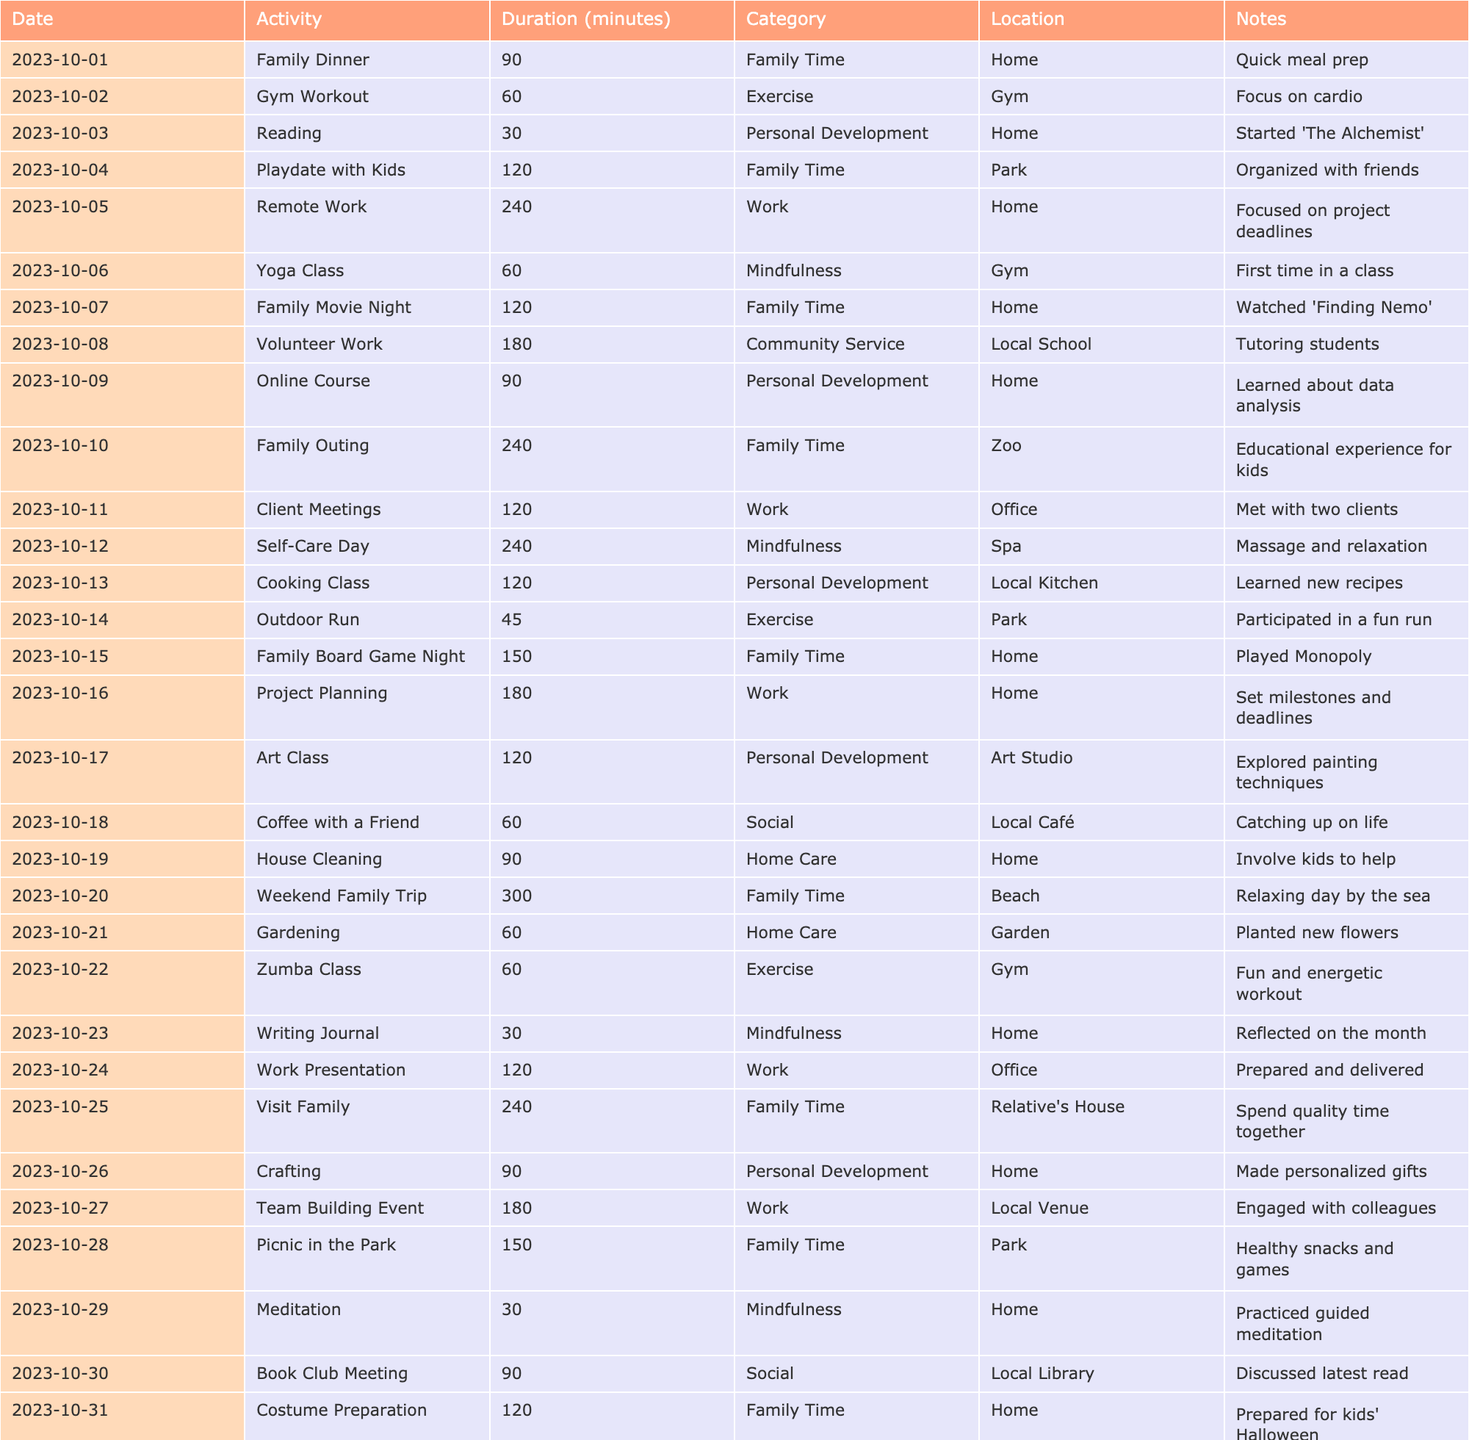What activity had the longest duration? Looking at the "Duration" column, the longest entry is "Weekend Family Trip" with 300 minutes.
Answer: Weekend Family Trip How many activities were related to family time? By counting the entries in the "Category" for Family Time, there are 8 such activities: Family Dinner, Playdate with Kids, Family Movie Night, Family Outing, Family Board Game Night, Weekend Family Trip, Visit Family, and Picnic in the Park.
Answer: 8 What was the total time spent on work-related activities? Summing the durations of the work-related activities (Remote Work 240 + Client Meetings 120 + Project Planning 180 + Work Presentation 120 + Team Building Event 180) gives 240 + 120 + 180 + 120 + 180 = 840 minutes.
Answer: 840 minutes Did the person engage in any mindfulness activities? By checking the table, the activities categorized under Mindfulness are Yoga Class, Self-Care Day, Writing Journal, and Meditation, confirming that there were mindfulness activities.
Answer: Yes What is the average duration of personal development activities? The personal development activities are Reading (30), Online Course (90), Cooking Class (120), Art Class (120), and Crafting (90). Their total is 30 + 90 + 120 + 120 + 90 = 450 minutes; the average is 450 / 5 = 90 minutes.
Answer: 90 minutes Which day had the least amount of time spent on activities? Evaluating the duration of activities by day, the lowest is "Meditation" on the 29th with 30 minutes.
Answer: Meditation on the 29th How many of the total activities were done at home? The activities done at home are Family Dinner, Remote Work, Family Movie Night, Online Course, Self-Care Day, Writing Journal, House Cleaning, and Costume Preparation, totaling 8.
Answer: 8 What percentage of the month's activities were related to family time? There are 31 activities in total and 8 of them relate to family time, so the percentage is (8/31) * 100 = approximately 25.8%.
Answer: Approximately 25.8% Was there an activity related to community service? Yes, "Volunteer Work" on the 8th is categorized under Community Service.
Answer: Yes What was the total time spent on exercise-related activities? Adding the durations of the exercise activities: Gym Workout (60) + Outdoor Run (45) + Zumba Class (60) gives 60 + 45 + 60 = 165 minutes in total.
Answer: 165 minutes 